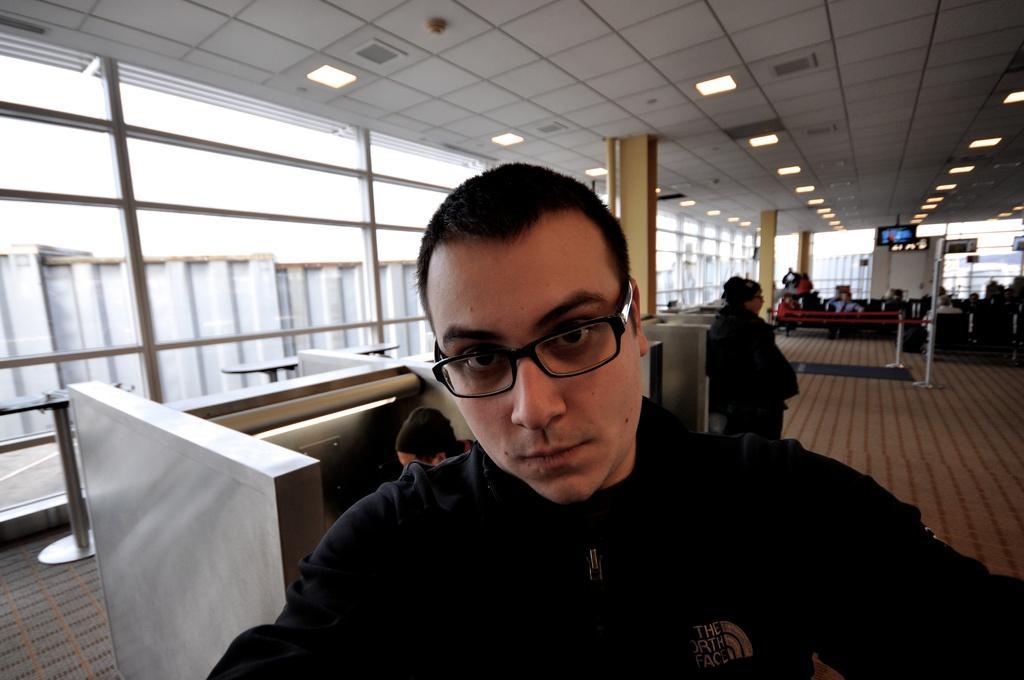Describe this image in one or two sentences. In this image we can see a group of people. On the left side of the image we can see some table and metal poles. On the right side of the image we can see some people sitting on chairs and a television on the stand. In the center of the image we can see pillars and a pipe. At the top of the image we can see some lights on the roof. 